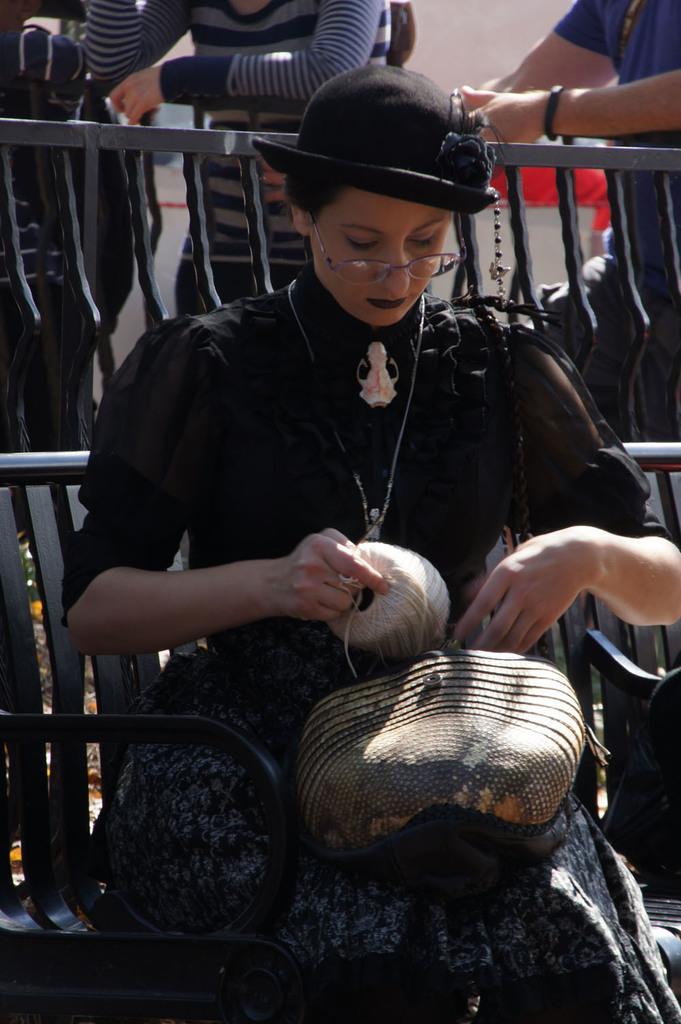How would you summarize this image in a sentence or two? In the image there is a woman sitting on a bench and doing some work, she is wearing black dress and black hat. Behind the woman there is a fence and behind the fence there are two people standing beside the fence. 